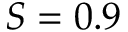<formula> <loc_0><loc_0><loc_500><loc_500>S = 0 . 9</formula> 